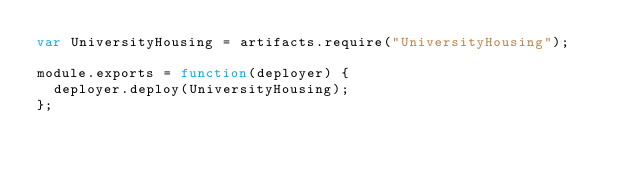Convert code to text. <code><loc_0><loc_0><loc_500><loc_500><_JavaScript_>var UniversityHousing = artifacts.require("UniversityHousing");

module.exports = function(deployer) {
  deployer.deploy(UniversityHousing);
};</code> 